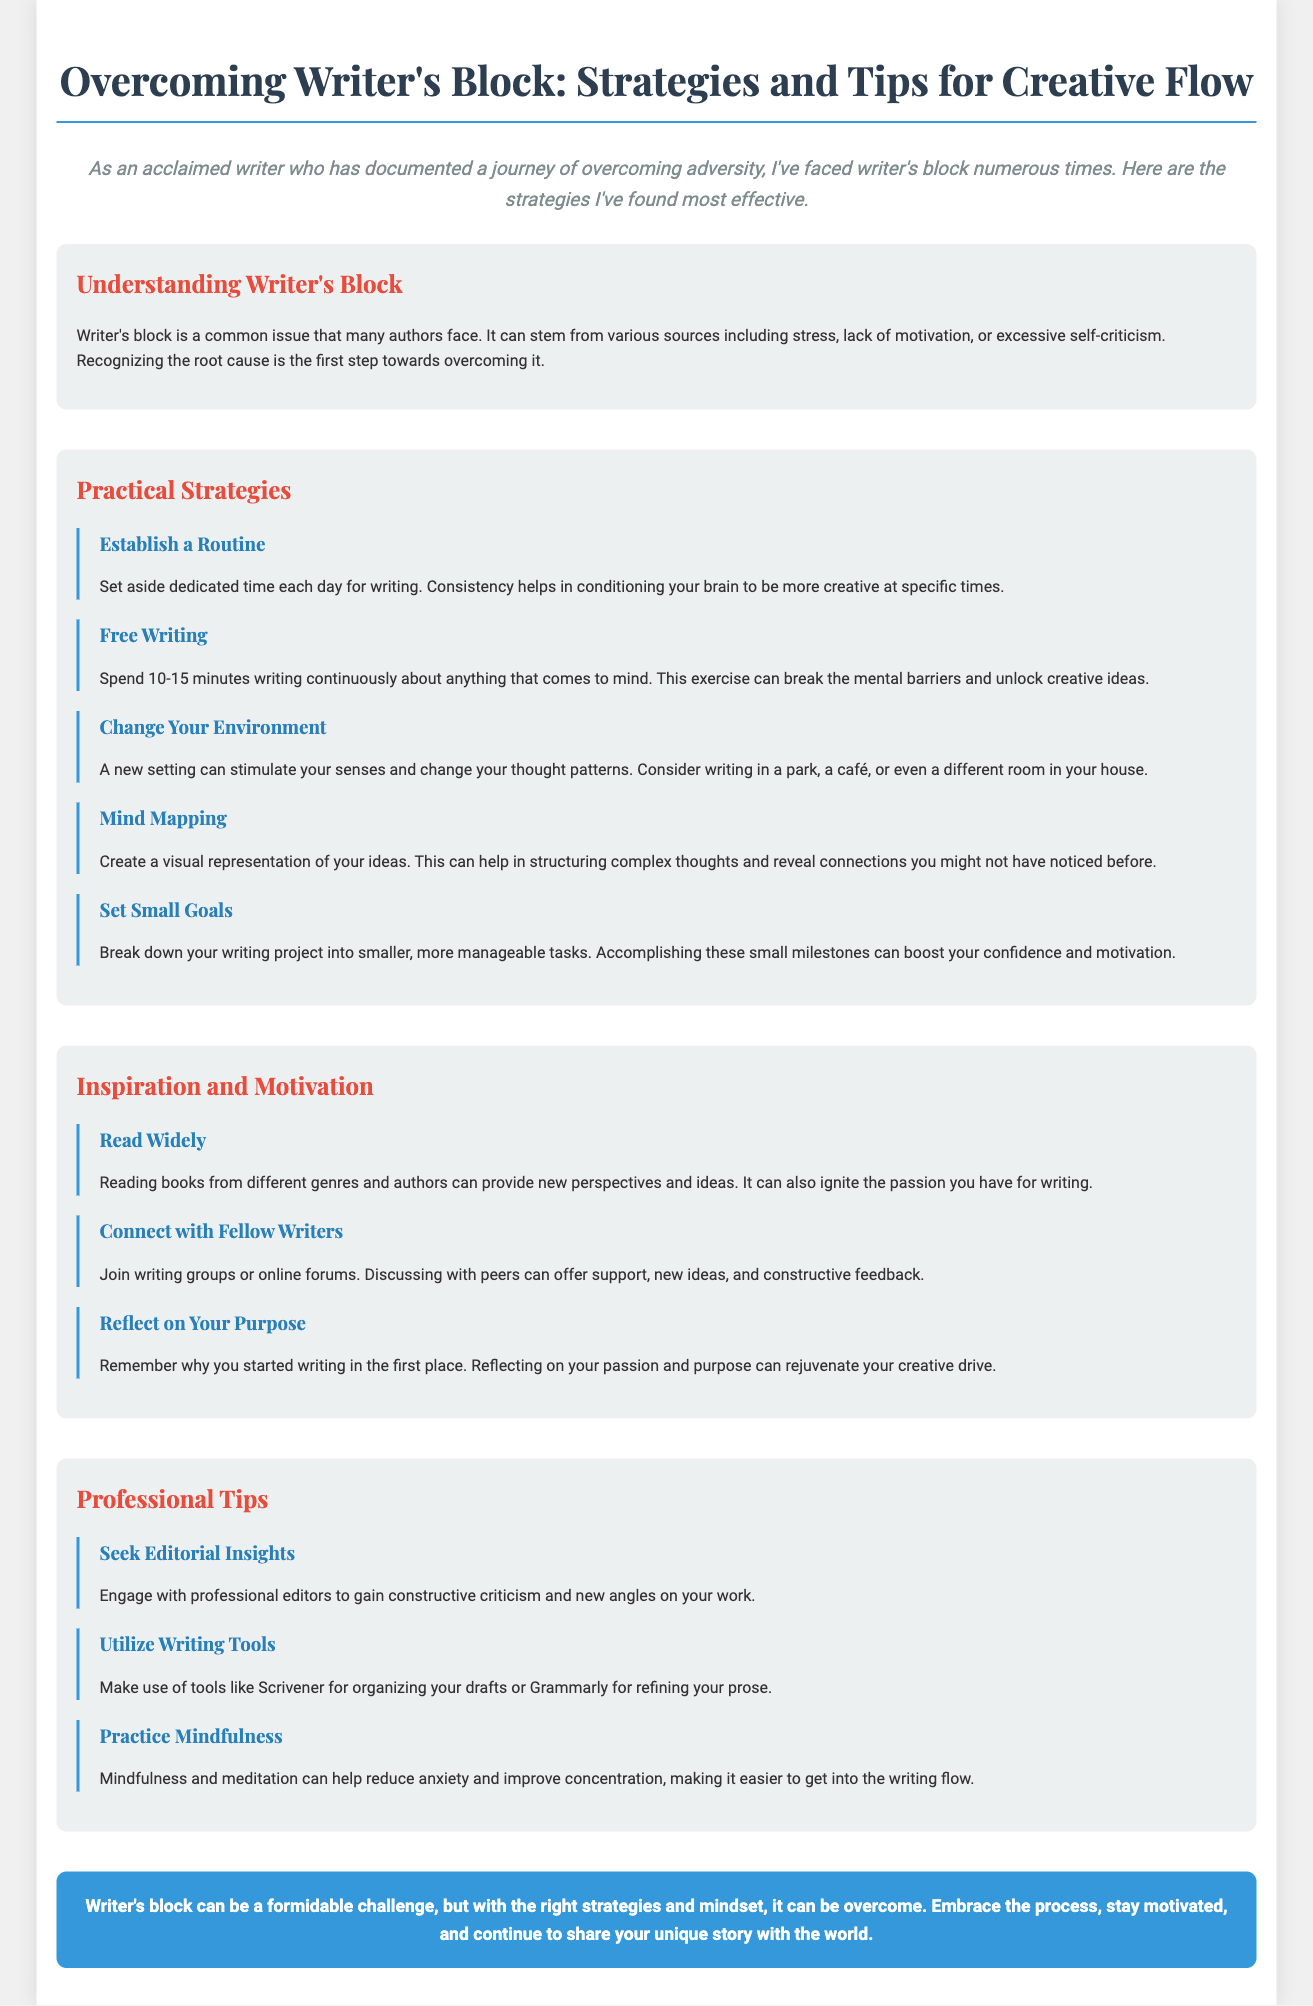What is the title of the infographic? The title of the infographic is prominently displayed at the top, indicating the main subject of the content.
Answer: Overcoming Writer's Block: Strategies and Tips for Creative Flow How many practical strategies are listed? The infographic includes a section dedicated to practical strategies for overcoming writer's block, which contains multiple strategies outlined.
Answer: Five What is one method suggested for inspiration? The document provides various suggestions for finding inspiration, which are highlighted in a specific section.
Answer: Read Widely What does free writing help to achieve? Free writing is mentioned as a strategy that serves a specific purpose within the context of overcoming creativity challenges.
Answer: Break the mental barriers What is the purpose of establishing a routine? The infographic describes the benefits of having a writing routine within the context of enhancing productivity and creativity.
Answer: Conditioning your brain Who should you connect with for support? The infographic encourages the benefits of collaboration and support among writers through community engagement.
Answer: Fellow Writers What mindfulness practice is recommended? The document includes professional tips, one of which emphasizes the importance of mindfulness in the writing process.
Answer: Practice Mindfulness What is a key takeaway from the conclusion? The conclusion summarizes the main message of the document regarding overcoming challenges faced by writers.
Answer: Embrace the process 